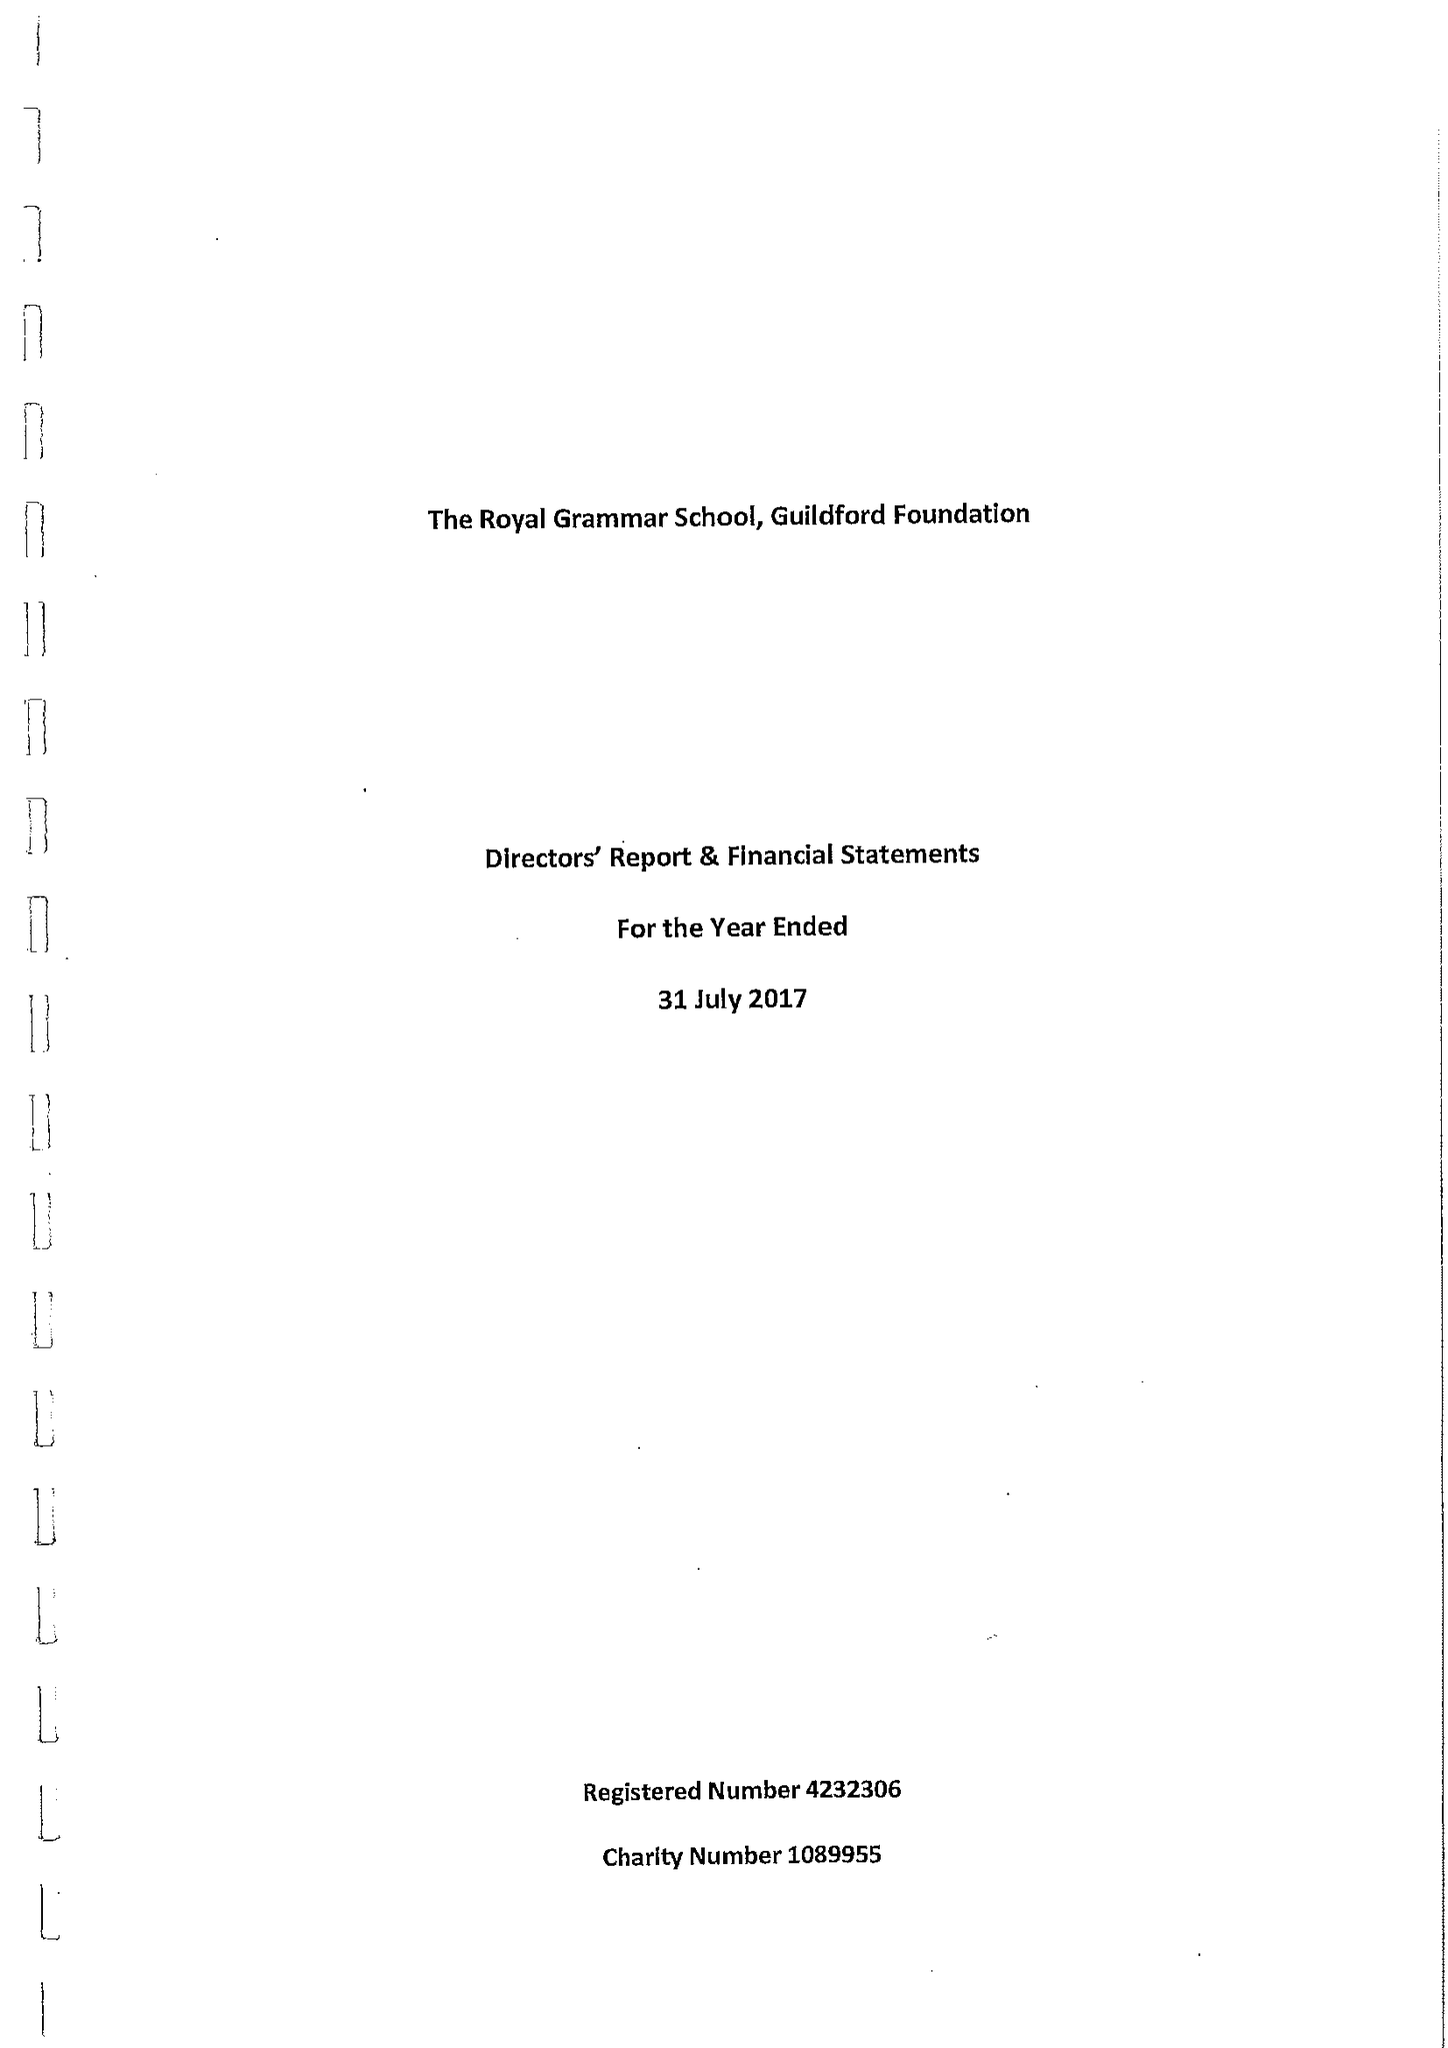What is the value for the address__postcode?
Answer the question using a single word or phrase. GU1 3BB 